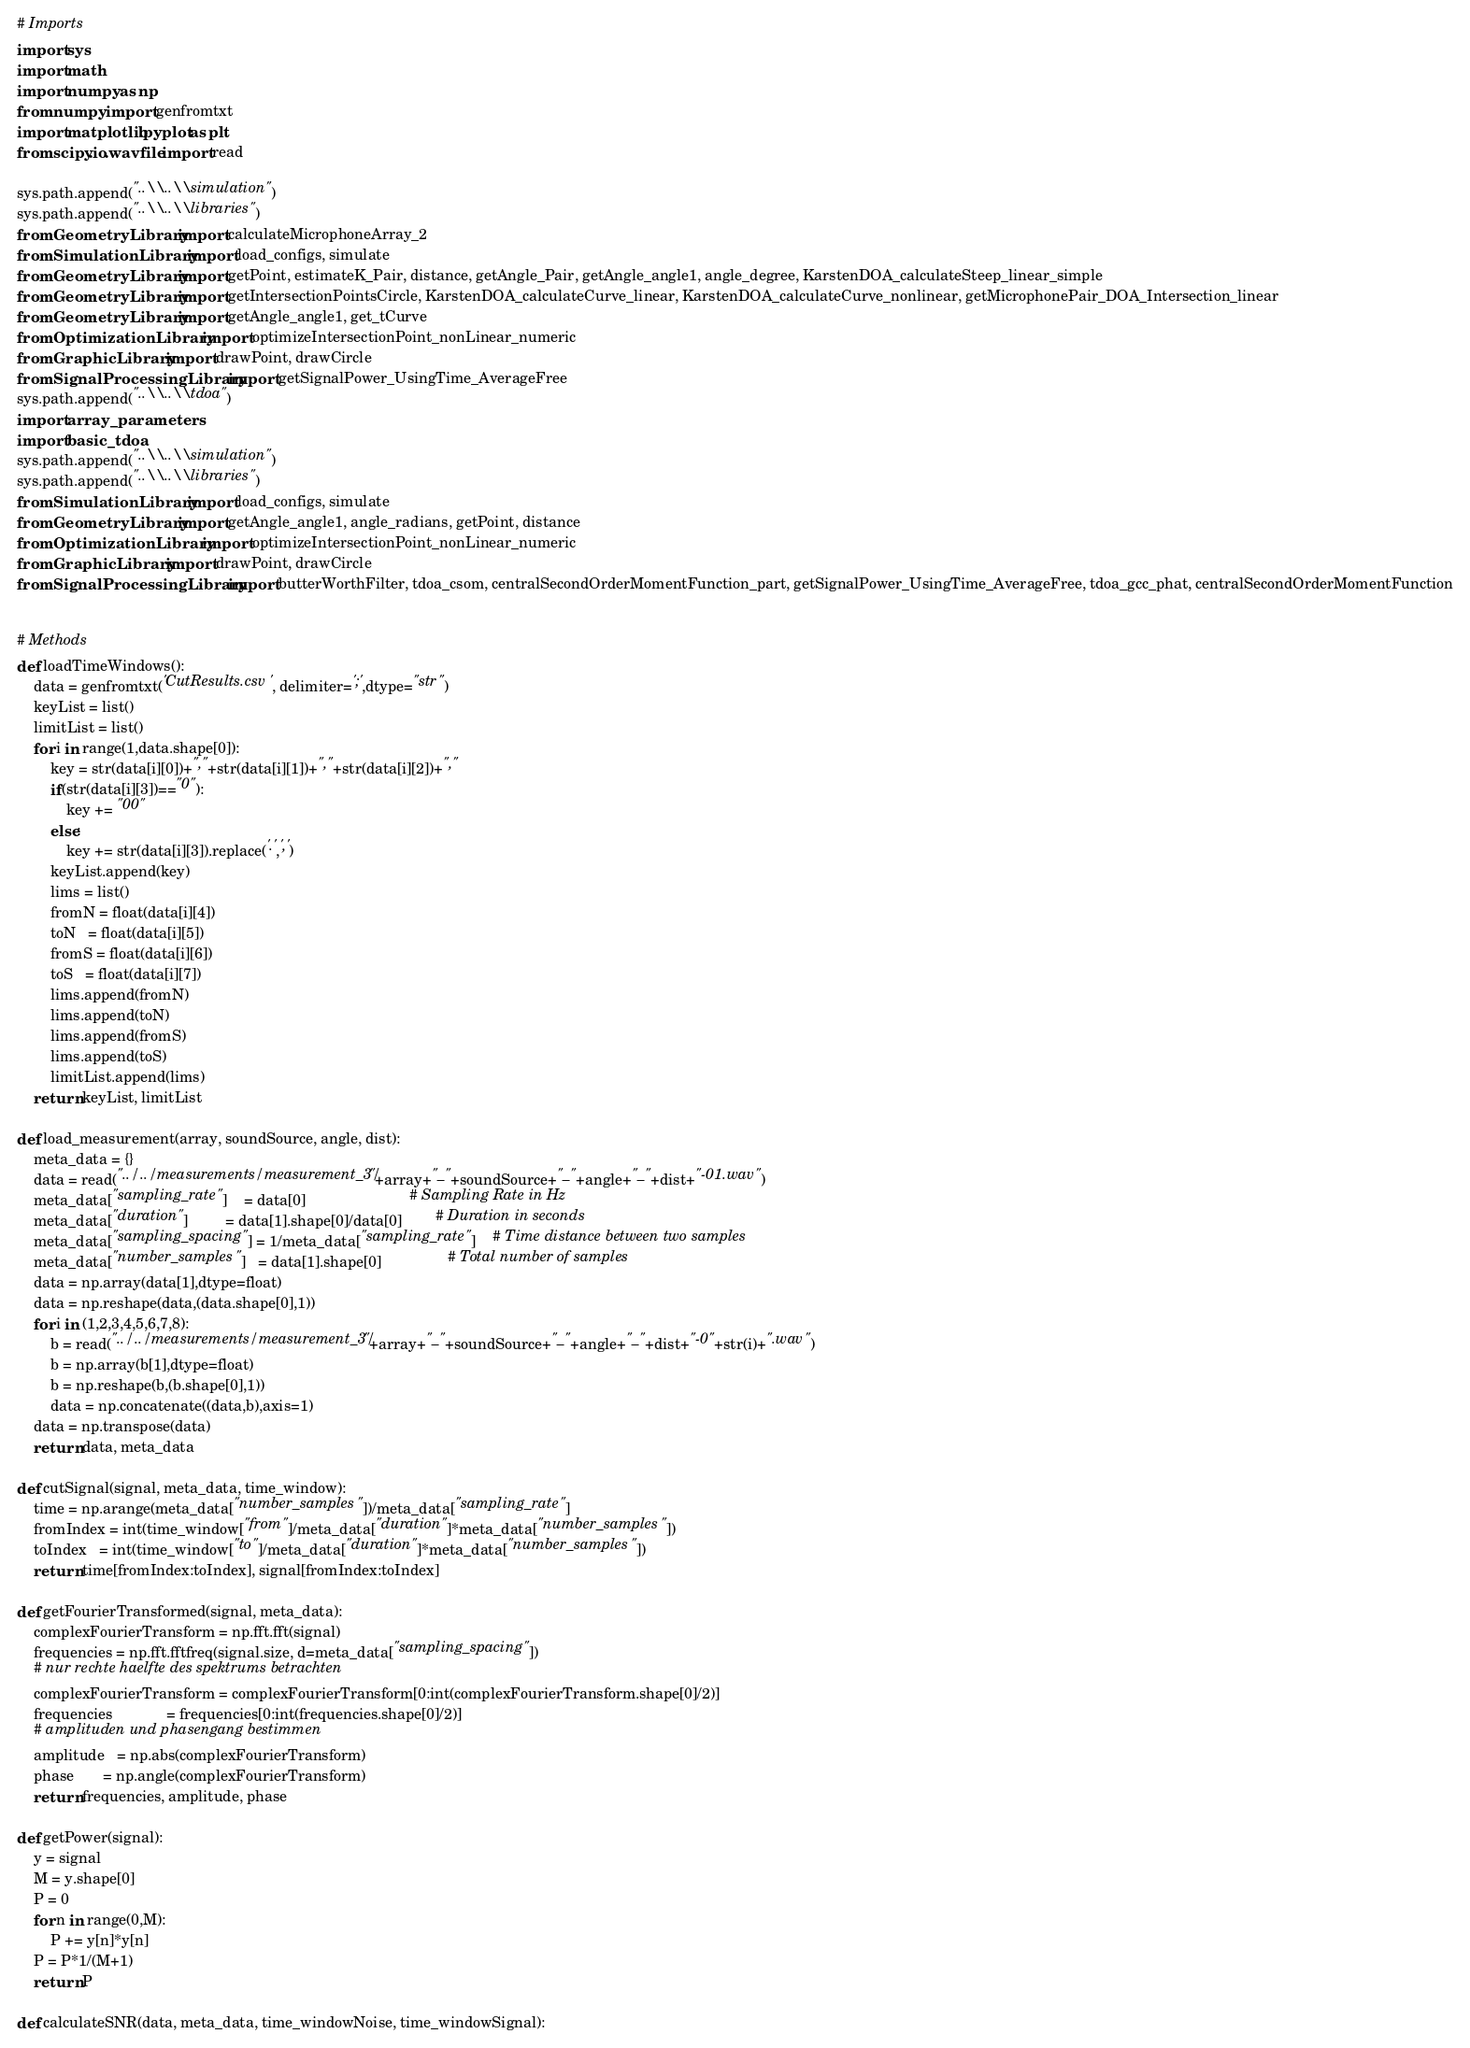Convert code to text. <code><loc_0><loc_0><loc_500><loc_500><_Python_># Imports
import sys
import math
import numpy as np
from numpy import genfromtxt
import matplotlib.pyplot as plt
from scipy.io.wavfile import read

sys.path.append("..\\..\\simulation")
sys.path.append("..\\..\\libraries")
from GeometryLibrary import calculateMicrophoneArray_2
from SimulationLibrary import load_configs, simulate
from GeometryLibrary import getPoint, estimateK_Pair, distance, getAngle_Pair, getAngle_angle1, angle_degree, KarstenDOA_calculateSteep_linear_simple
from GeometryLibrary import getIntersectionPointsCircle, KarstenDOA_calculateCurve_linear, KarstenDOA_calculateCurve_nonlinear, getMicrophonePair_DOA_Intersection_linear
from GeometryLibrary import getAngle_angle1, get_tCurve
from OptimizationLibrary import optimizeIntersectionPoint_nonLinear_numeric
from GraphicLibrary import drawPoint, drawCircle
from SignalProcessingLibrary import getSignalPower_UsingTime_AverageFree
sys.path.append("..\\..\\tdoa")
import array_parameters
import basic_tdoa
sys.path.append("..\\..\\simulation")
sys.path.append("..\\..\\libraries")
from SimulationLibrary import load_configs, simulate
from GeometryLibrary import getAngle_angle1, angle_radians, getPoint, distance
from OptimizationLibrary import optimizeIntersectionPoint_nonLinear_numeric
from GraphicLibrary import drawPoint, drawCircle
from SignalProcessingLibrary import butterWorthFilter, tdoa_csom, centralSecondOrderMomentFunction_part, getSignalPower_UsingTime_AverageFree, tdoa_gcc_phat, centralSecondOrderMomentFunction


# Methods
def loadTimeWindows():
    data = genfromtxt('CutResults.csv', delimiter=';',dtype="str")    
    keyList = list()
    limitList = list()    
    for i in range(1,data.shape[0]):
        key = str(data[i][0])+","+str(data[i][1])+","+str(data[i][2])+","
        if(str(data[i][3])=="0"):
            key += "00"
        else:
            key += str(data[i][3]).replace('.',',')
        keyList.append(key)        
        lims = list()
        fromN = float(data[i][4])
        toN   = float(data[i][5])
        fromS = float(data[i][6])
        toS   = float(data[i][7])
        lims.append(fromN)
        lims.append(toN)
        lims.append(fromS)
        lims.append(toS)
        limitList.append(lims)        
    return keyList, limitList

def load_measurement(array, soundSource, angle, dist):    
    meta_data = {}
    data = read("../../measurements/measurement_3/"+array+"_"+soundSource+"_"+angle+"_"+dist+"-01.wav")
    meta_data["sampling_rate"]    = data[0]                         # Sampling Rate in Hz
    meta_data["duration"]         = data[1].shape[0]/data[0]        # Duration in seconds
    meta_data["sampling_spacing"] = 1/meta_data["sampling_rate"]    # Time distance between two samples
    meta_data["number_samples"]   = data[1].shape[0]                # Total number of samples    
    data = np.array(data[1],dtype=float)
    data = np.reshape(data,(data.shape[0],1))
    for i in (1,2,3,4,5,6,7,8):
        b = read("../../measurements/measurement_3/"+array+"_"+soundSource+"_"+angle+"_"+dist+"-0"+str(i)+".wav")
        b = np.array(b[1],dtype=float)
        b = np.reshape(b,(b.shape[0],1))
        data = np.concatenate((data,b),axis=1)
    data = np.transpose(data)    
    return data, meta_data

def cutSignal(signal, meta_data, time_window):
    time = np.arange(meta_data["number_samples"])/meta_data["sampling_rate"] 
    fromIndex = int(time_window["from"]/meta_data["duration"]*meta_data["number_samples"])
    toIndex   = int(time_window["to"]/meta_data["duration"]*meta_data["number_samples"])    
    return time[fromIndex:toIndex], signal[fromIndex:toIndex]

def getFourierTransformed(signal, meta_data):
    complexFourierTransform = np.fft.fft(signal)
    frequencies = np.fft.fftfreq(signal.size, d=meta_data["sampling_spacing"])    
    # nur rechte haelfte des spektrums betrachten
    complexFourierTransform = complexFourierTransform[0:int(complexFourierTransform.shape[0]/2)]
    frequencies             = frequencies[0:int(frequencies.shape[0]/2)]    
    # amplituden und phasengang bestimmen
    amplitude   = np.abs(complexFourierTransform)
    phase       = np.angle(complexFourierTransform)    
    return frequencies, amplitude, phase

def getPower(signal):
    y = signal
    M = y.shape[0]
    P = 0
    for n in range(0,M):
        P += y[n]*y[n]
    P = P*1/(M+1)
    return P

def calculateSNR(data, meta_data, time_windowNoise, time_windowSignal):</code> 